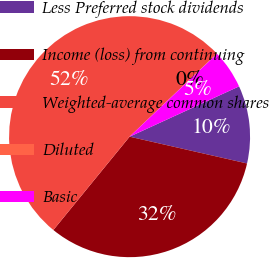<chart> <loc_0><loc_0><loc_500><loc_500><pie_chart><fcel>Less Preferred stock dividends<fcel>Income (loss) from continuing<fcel>Weighted-average common shares<fcel>Diluted<fcel>Basic<nl><fcel>10.42%<fcel>32.33%<fcel>52.0%<fcel>0.03%<fcel>5.22%<nl></chart> 